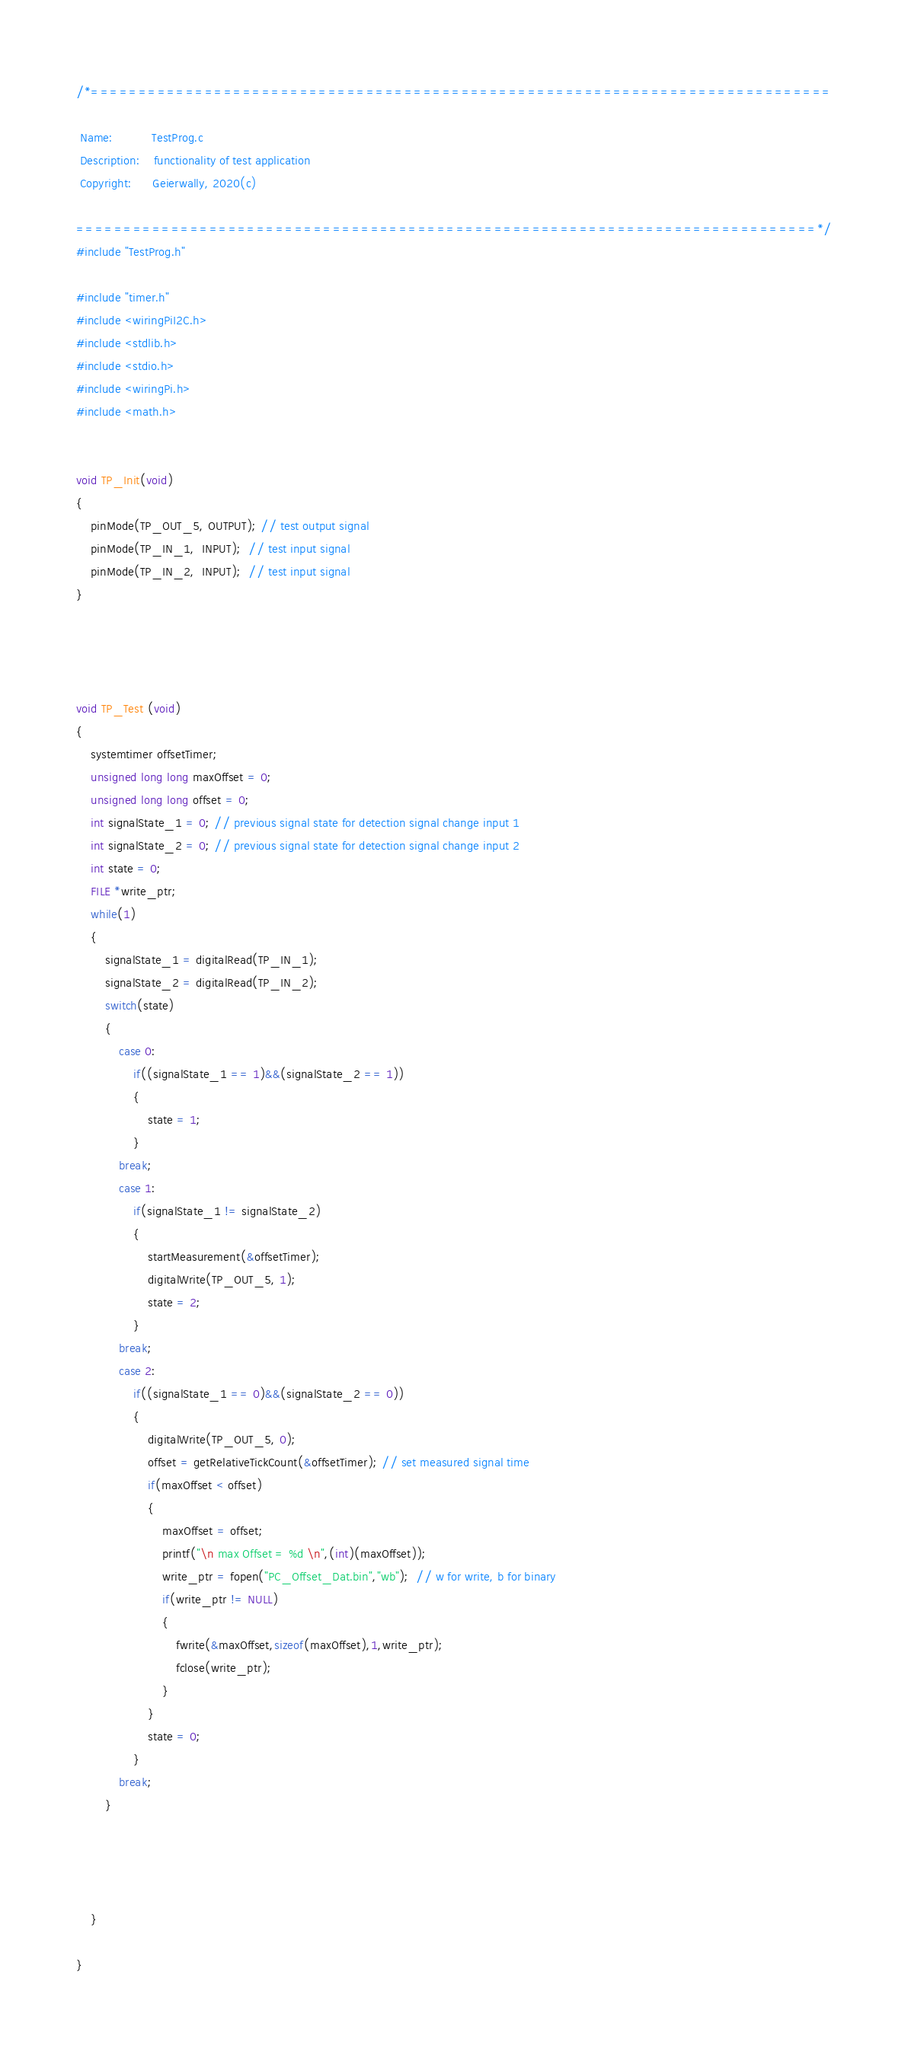<code> <loc_0><loc_0><loc_500><loc_500><_C_>/*==============================================================================

 Name:           TestProg.c
 Description:    functionality of test application
 Copyright:      Geierwally, 2020(c)

==============================================================================*/
#include "TestProg.h"

#include "timer.h"
#include <wiringPiI2C.h>
#include <stdlib.h>
#include <stdio.h>
#include <wiringPi.h>
#include <math.h>


void TP_Init(void)
{
	pinMode(TP_OUT_5, OUTPUT); // test output signal
	pinMode(TP_IN_1,  INPUT);  // test input signal
	pinMode(TP_IN_2,  INPUT);  // test input signal
}




void TP_Test (void)
{
	systemtimer offsetTimer;
	unsigned long long maxOffset = 0;
	unsigned long long offset = 0;
	int signalState_1 = 0; // previous signal state for detection signal change input 1
	int signalState_2 = 0; // previous signal state for detection signal change input 2
	int state = 0;
	FILE *write_ptr;
	while(1)
	{
		signalState_1 = digitalRead(TP_IN_1);
		signalState_2 = digitalRead(TP_IN_2);
		switch(state)
		{
			case 0:
				if((signalState_1 == 1)&&(signalState_2 == 1))
				{
					state = 1;
				}
			break;
			case 1:
				if(signalState_1 != signalState_2)
				{
					startMeasurement(&offsetTimer);
					digitalWrite(TP_OUT_5, 1);
					state = 2;
				}
			break;
			case 2:
				if((signalState_1 == 0)&&(signalState_2 == 0))
				{
					digitalWrite(TP_OUT_5, 0);
					offset = getRelativeTickCount(&offsetTimer); // set measured signal time
					if(maxOffset < offset)
					{
						maxOffset = offset;
						printf("\n max Offset = %d \n",(int)(maxOffset));
						write_ptr = fopen("PC_Offset_Dat.bin","wb");  // w for write, b for binary
						if(write_ptr != NULL)
						{
							fwrite(&maxOffset,sizeof(maxOffset),1,write_ptr);
							fclose(write_ptr);
						}
					}
					state = 0;
				}
			break;
		}




	}

}
</code> 